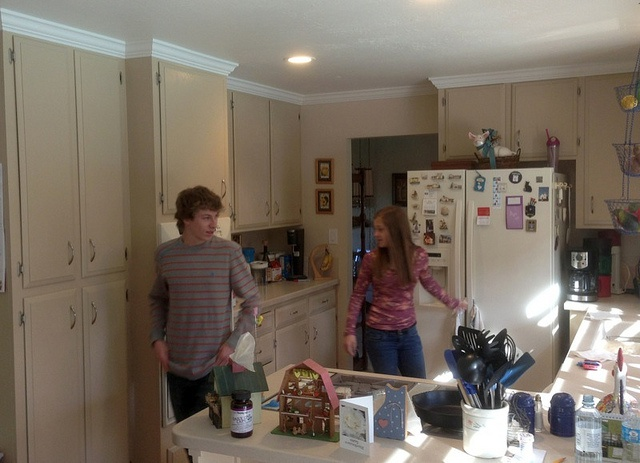Describe the objects in this image and their specific colors. I can see refrigerator in gray, darkgray, and white tones, people in gray, black, and maroon tones, people in gray, black, maroon, and brown tones, refrigerator in gray and darkgray tones, and sink in gray, white, lightgray, and darkgray tones in this image. 